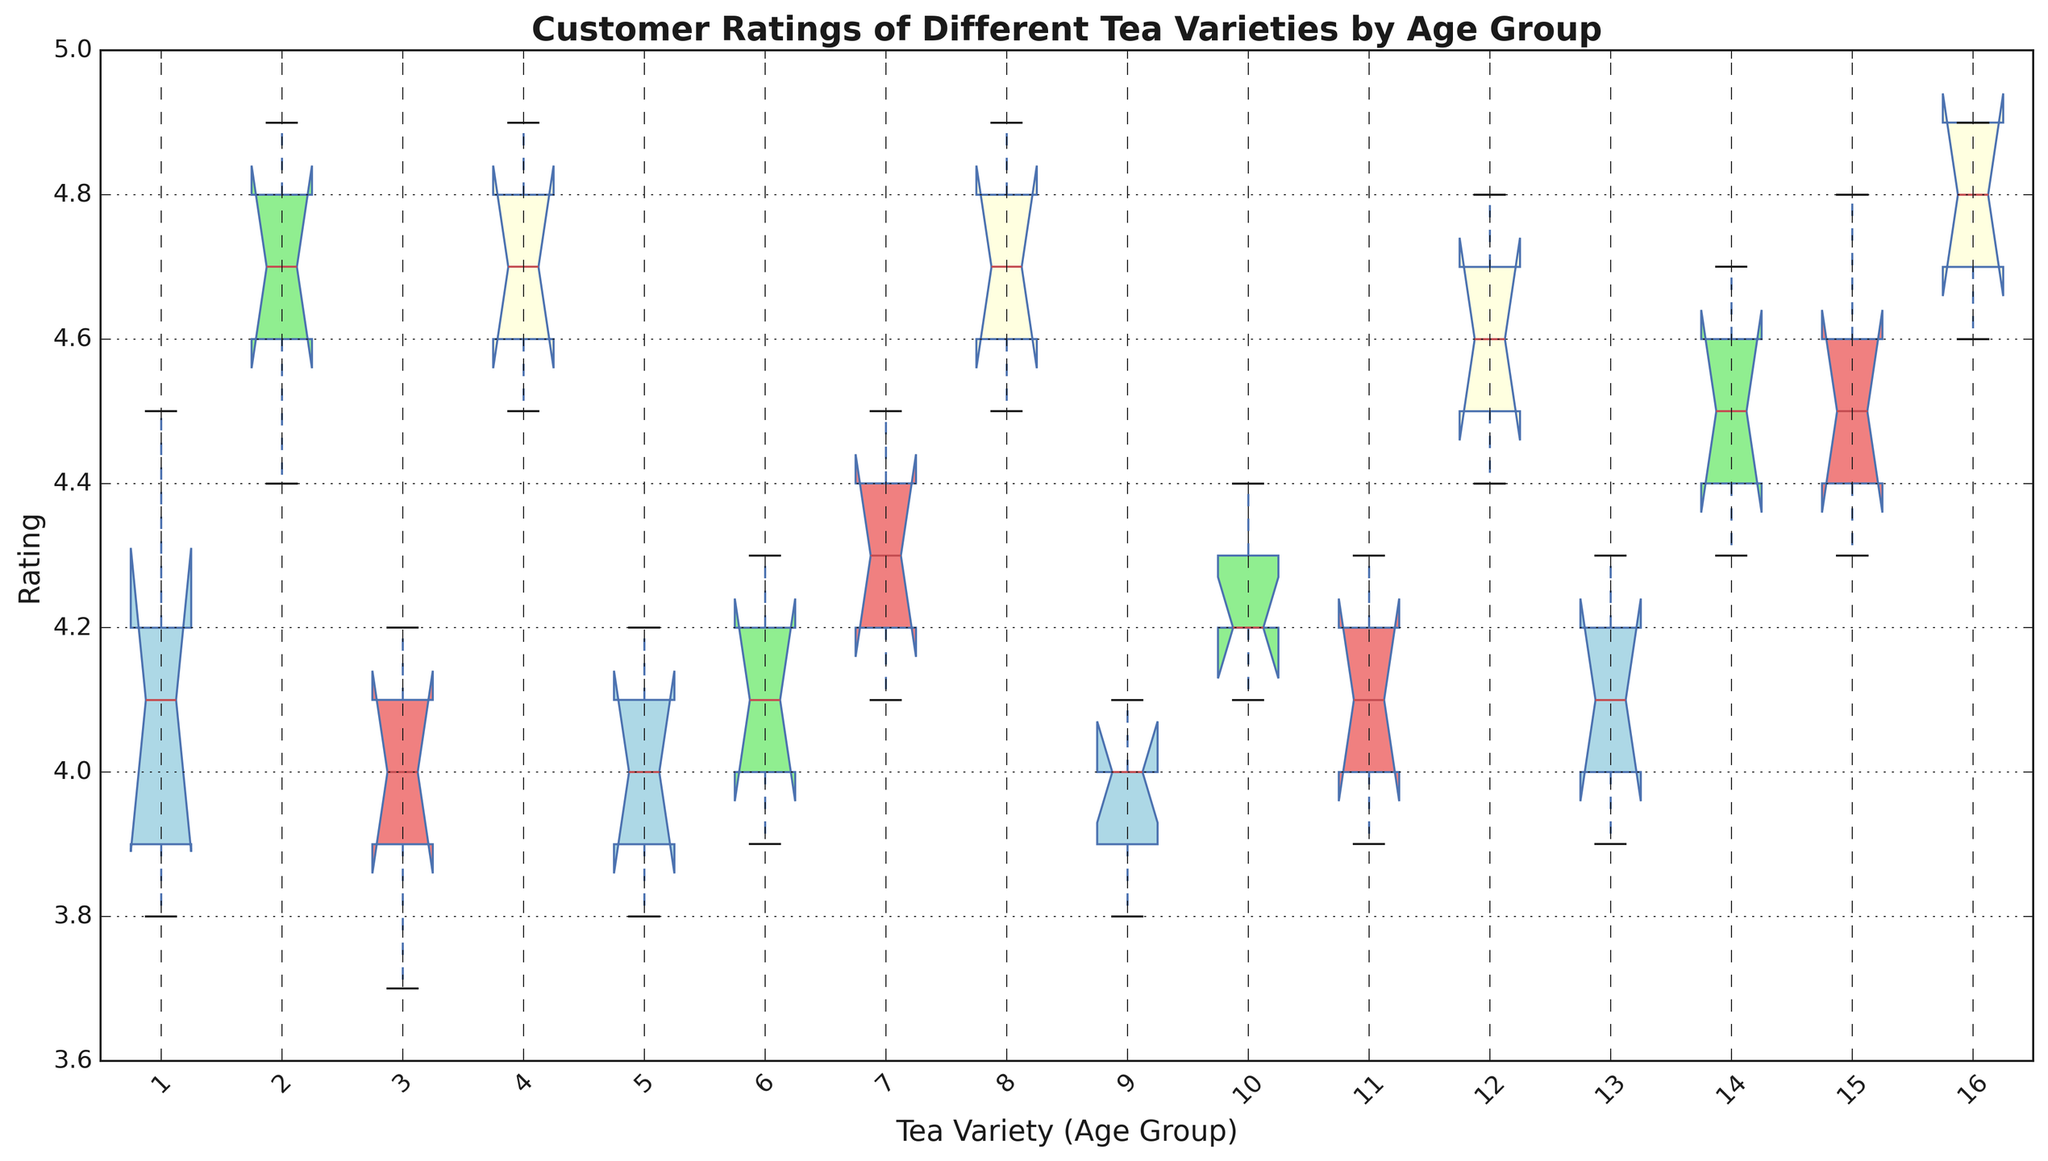What is the median rating of Earl Grey for the 25-34 age group? Locate the median line within the box plot section corresponding to "Earl Grey (25-34)" in the figure. The median is marked by the line inside the interquartile range box.
Answer: 4.7 Which tea variety has the widest range of ratings for the 45-54 age group? To determine the tea variety with the widest range of ratings, look at the distance between the top and bottom whiskers in each box plot for the 45-54 age group. Identify which tea variety has the longest whisker span.
Answer: Peppermint What is the interquartile range (IQR) of Green Tea for the 35-44 age group? The interquartile range (IQR) is the difference between the third quartile (Q3) and the first quartile (Q1). Examine the box plot section for "Green Tea (35-44)" to identify Q1 (bottom edge of the box) and Q3 (top edge of the box). Compute the difference between these two values.
Answer: 0.3 Which tea variety shows the highest median rating for the 18-24 age group? Look at the median lines inside the boxes for all tea varieties listed under the 18-24 age group. The tea variety with the highest position of the median line has the highest median rating.
Answer: Earl Grey What is the difference in median ratings between the 18-24 and 45-54 age groups for Chamomile? Locate the median lines within the boxes of "Chamomile (18-24)" and "Chamomile (45-54)" in the box plot, noting their numerical values. Subtract the median value of the 18-24 group from the median value of the 45-54 group.
Answer: 0.7 Among all age groups, which tea variety has the most consistent ratings (smallest IQR)? To determine the most consistent ratings, compare the IQRs (interquartile ranges) of each tea variety across all age groups. The tea variety with the shortest height in its boxes represents the smallest IQR, indicating the most consistent ratings.
Answer: Green Tea Which age group shows the highest variability in ratings for Peppermint? Variability is indicated by the range or span of the box plot, including whiskers. Identify the age group for Peppermint that has the widest box plot, including whiskers.
Answer: 35-44 How do the median ratings of Green Tea compare between the 25-34 and 35-44 age groups? Compare the median lines inside the boxes of "Green Tea (25-34)" and "Green Tea (35-44)." The relative positions of these lines will reveal whether the median rating is higher, lower, or equal between the two age groups.
Answer: Lower in 25-34 What are the upper and lower whiskers for Chamomile in the 45-54 age group? The whiskers represent the minimum and maximum ratings excluding any outliers. Identify the ends of the whiskers for "Chamomile (45-54)" in the box plot to determine these values.
Answer: 4.4 and 4.8 